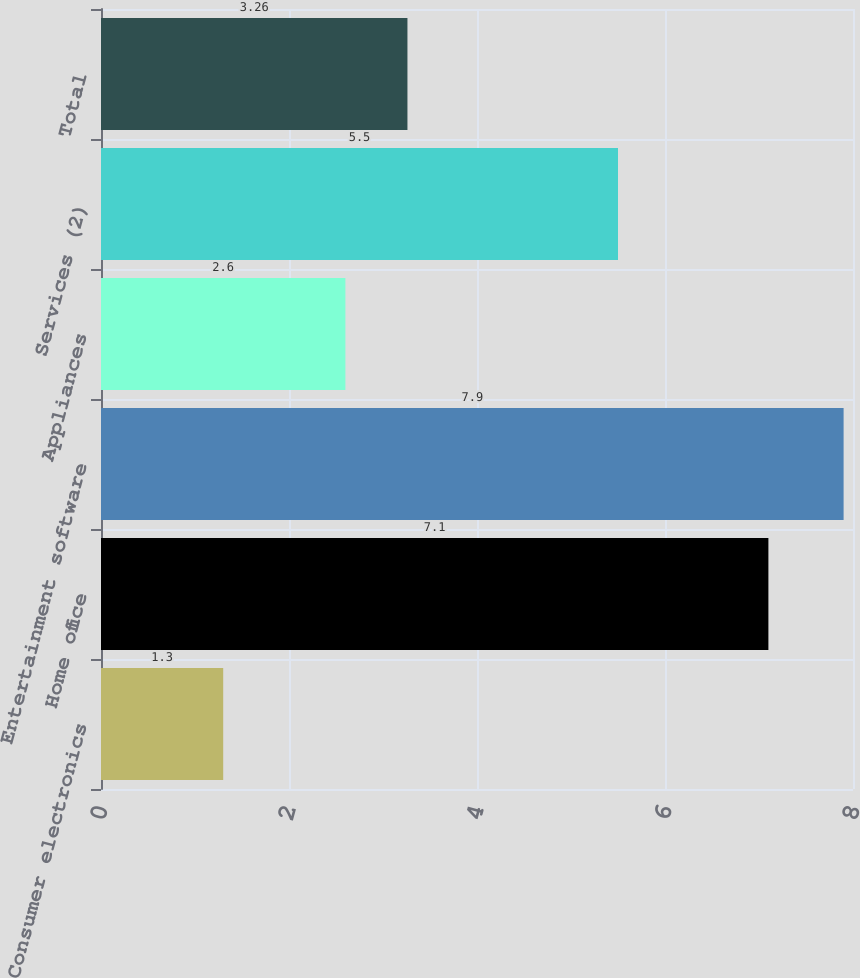Convert chart. <chart><loc_0><loc_0><loc_500><loc_500><bar_chart><fcel>Consumer electronics<fcel>Home office<fcel>Entertainment software<fcel>Appliances<fcel>Services (2)<fcel>Total<nl><fcel>1.3<fcel>7.1<fcel>7.9<fcel>2.6<fcel>5.5<fcel>3.26<nl></chart> 